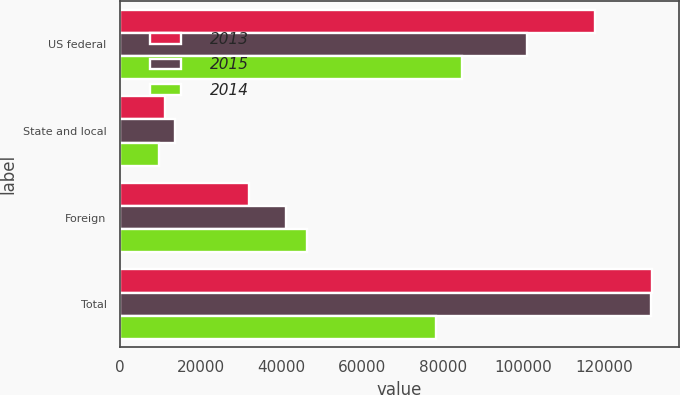Convert chart. <chart><loc_0><loc_0><loc_500><loc_500><stacked_bar_chart><ecel><fcel>US federal<fcel>State and local<fcel>Foreign<fcel>Total<nl><fcel>2013<fcel>117602<fcel>11175<fcel>31981<fcel>131875<nl><fcel>2015<fcel>100826<fcel>13686<fcel>41151<fcel>131637<nl><fcel>2014<fcel>84686<fcel>9774<fcel>46450<fcel>78385<nl></chart> 